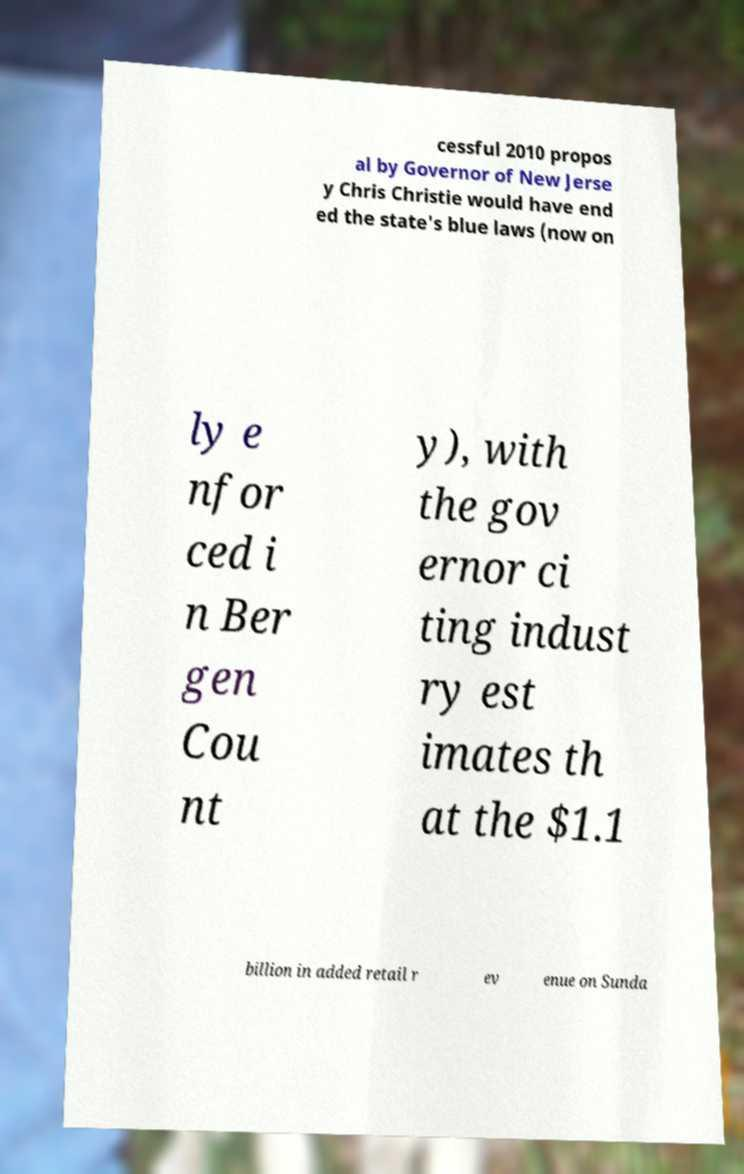For documentation purposes, I need the text within this image transcribed. Could you provide that? cessful 2010 propos al by Governor of New Jerse y Chris Christie would have end ed the state's blue laws (now on ly e nfor ced i n Ber gen Cou nt y), with the gov ernor ci ting indust ry est imates th at the $1.1 billion in added retail r ev enue on Sunda 